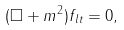<formula> <loc_0><loc_0><loc_500><loc_500>( \Box + m ^ { 2 } ) f _ { l t } = 0 ,</formula> 